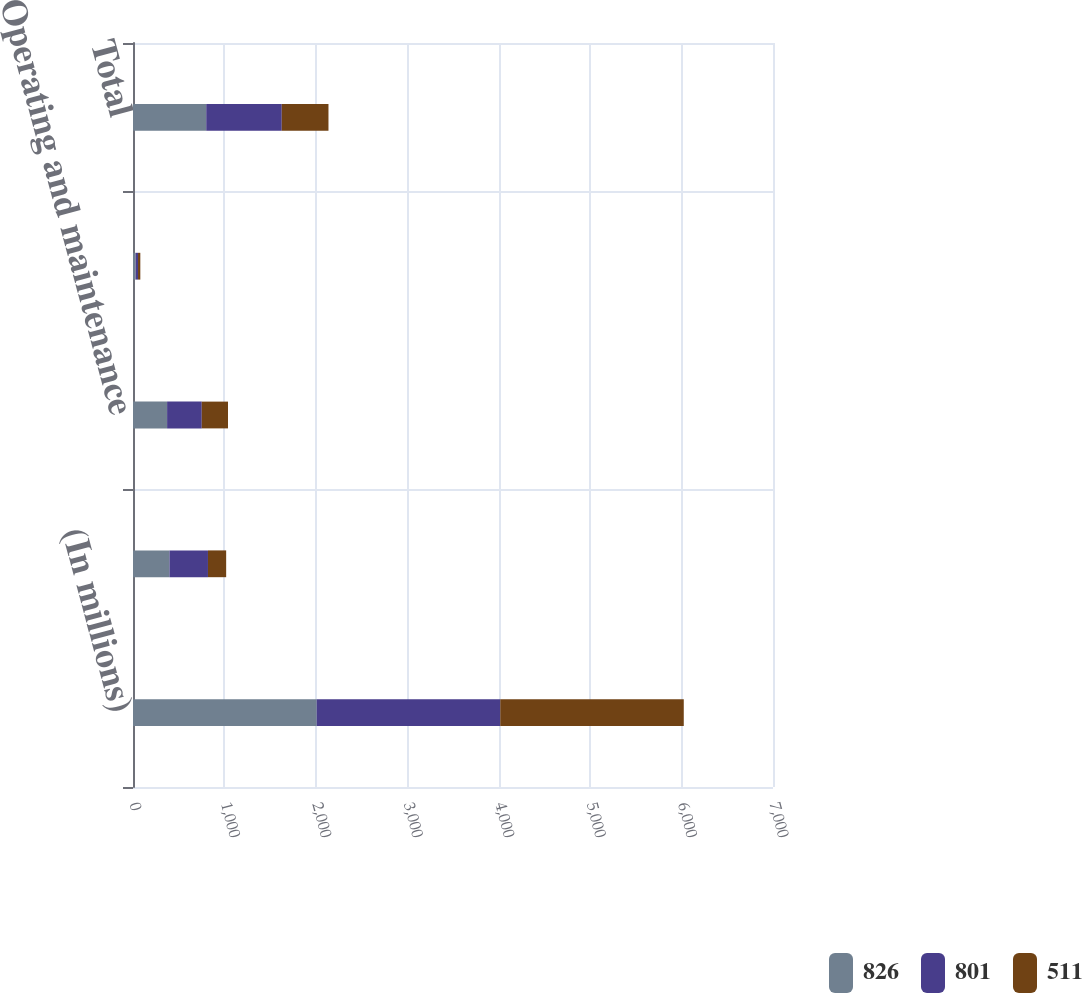<chart> <loc_0><loc_0><loc_500><loc_500><stacked_bar_chart><ecel><fcel>(In millions)<fcel>Capital<fcel>Operating and maintenance<fcel>Remediation (b)<fcel>Total<nl><fcel>826<fcel>2009<fcel>399<fcel>373<fcel>29<fcel>801<nl><fcel>801<fcel>2008<fcel>421<fcel>379<fcel>26<fcel>826<nl><fcel>511<fcel>2007<fcel>199<fcel>287<fcel>25<fcel>511<nl></chart> 